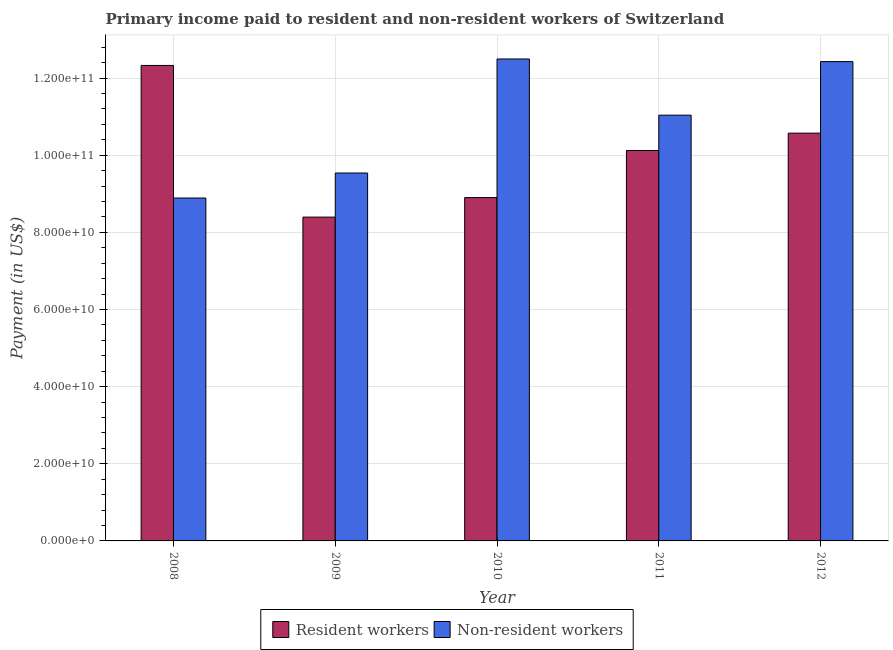How many different coloured bars are there?
Ensure brevity in your answer.  2. How many groups of bars are there?
Ensure brevity in your answer.  5. Are the number of bars per tick equal to the number of legend labels?
Ensure brevity in your answer.  Yes. Are the number of bars on each tick of the X-axis equal?
Provide a short and direct response. Yes. How many bars are there on the 1st tick from the left?
Your answer should be very brief. 2. How many bars are there on the 1st tick from the right?
Give a very brief answer. 2. What is the payment made to non-resident workers in 2011?
Your answer should be compact. 1.10e+11. Across all years, what is the maximum payment made to resident workers?
Keep it short and to the point. 1.23e+11. Across all years, what is the minimum payment made to non-resident workers?
Offer a terse response. 8.89e+1. In which year was the payment made to resident workers maximum?
Make the answer very short. 2008. In which year was the payment made to resident workers minimum?
Offer a terse response. 2009. What is the total payment made to resident workers in the graph?
Your answer should be very brief. 5.03e+11. What is the difference between the payment made to resident workers in 2008 and that in 2010?
Your answer should be very brief. 3.43e+1. What is the difference between the payment made to resident workers in 2008 and the payment made to non-resident workers in 2010?
Keep it short and to the point. 3.43e+1. What is the average payment made to non-resident workers per year?
Ensure brevity in your answer.  1.09e+11. In the year 2011, what is the difference between the payment made to resident workers and payment made to non-resident workers?
Give a very brief answer. 0. What is the ratio of the payment made to resident workers in 2008 to that in 2012?
Provide a short and direct response. 1.17. Is the payment made to resident workers in 2009 less than that in 2012?
Keep it short and to the point. Yes. Is the difference between the payment made to resident workers in 2011 and 2012 greater than the difference between the payment made to non-resident workers in 2011 and 2012?
Provide a succinct answer. No. What is the difference between the highest and the second highest payment made to resident workers?
Keep it short and to the point. 1.76e+1. What is the difference between the highest and the lowest payment made to non-resident workers?
Ensure brevity in your answer.  3.60e+1. What does the 1st bar from the left in 2012 represents?
Offer a terse response. Resident workers. What does the 1st bar from the right in 2011 represents?
Offer a terse response. Non-resident workers. How many bars are there?
Keep it short and to the point. 10. Are all the bars in the graph horizontal?
Provide a succinct answer. No. How many years are there in the graph?
Provide a short and direct response. 5. What is the difference between two consecutive major ticks on the Y-axis?
Your answer should be compact. 2.00e+1. Does the graph contain grids?
Offer a very short reply. Yes. How many legend labels are there?
Your answer should be very brief. 2. What is the title of the graph?
Keep it short and to the point. Primary income paid to resident and non-resident workers of Switzerland. What is the label or title of the Y-axis?
Your answer should be very brief. Payment (in US$). What is the Payment (in US$) in Resident workers in 2008?
Make the answer very short. 1.23e+11. What is the Payment (in US$) of Non-resident workers in 2008?
Provide a short and direct response. 8.89e+1. What is the Payment (in US$) of Resident workers in 2009?
Ensure brevity in your answer.  8.40e+1. What is the Payment (in US$) in Non-resident workers in 2009?
Ensure brevity in your answer.  9.54e+1. What is the Payment (in US$) of Resident workers in 2010?
Make the answer very short. 8.90e+1. What is the Payment (in US$) of Non-resident workers in 2010?
Offer a terse response. 1.25e+11. What is the Payment (in US$) in Resident workers in 2011?
Ensure brevity in your answer.  1.01e+11. What is the Payment (in US$) in Non-resident workers in 2011?
Offer a terse response. 1.10e+11. What is the Payment (in US$) in Resident workers in 2012?
Your answer should be very brief. 1.06e+11. What is the Payment (in US$) of Non-resident workers in 2012?
Offer a very short reply. 1.24e+11. Across all years, what is the maximum Payment (in US$) of Resident workers?
Keep it short and to the point. 1.23e+11. Across all years, what is the maximum Payment (in US$) of Non-resident workers?
Offer a terse response. 1.25e+11. Across all years, what is the minimum Payment (in US$) in Resident workers?
Keep it short and to the point. 8.40e+1. Across all years, what is the minimum Payment (in US$) in Non-resident workers?
Ensure brevity in your answer.  8.89e+1. What is the total Payment (in US$) of Resident workers in the graph?
Offer a terse response. 5.03e+11. What is the total Payment (in US$) of Non-resident workers in the graph?
Offer a terse response. 5.44e+11. What is the difference between the Payment (in US$) in Resident workers in 2008 and that in 2009?
Keep it short and to the point. 3.93e+1. What is the difference between the Payment (in US$) of Non-resident workers in 2008 and that in 2009?
Offer a very short reply. -6.48e+09. What is the difference between the Payment (in US$) of Resident workers in 2008 and that in 2010?
Ensure brevity in your answer.  3.43e+1. What is the difference between the Payment (in US$) in Non-resident workers in 2008 and that in 2010?
Offer a very short reply. -3.60e+1. What is the difference between the Payment (in US$) of Resident workers in 2008 and that in 2011?
Your answer should be very brief. 2.21e+1. What is the difference between the Payment (in US$) of Non-resident workers in 2008 and that in 2011?
Your response must be concise. -2.15e+1. What is the difference between the Payment (in US$) in Resident workers in 2008 and that in 2012?
Offer a terse response. 1.76e+1. What is the difference between the Payment (in US$) of Non-resident workers in 2008 and that in 2012?
Make the answer very short. -3.54e+1. What is the difference between the Payment (in US$) in Resident workers in 2009 and that in 2010?
Keep it short and to the point. -5.06e+09. What is the difference between the Payment (in US$) in Non-resident workers in 2009 and that in 2010?
Offer a very short reply. -2.96e+1. What is the difference between the Payment (in US$) of Resident workers in 2009 and that in 2011?
Ensure brevity in your answer.  -1.73e+1. What is the difference between the Payment (in US$) in Non-resident workers in 2009 and that in 2011?
Keep it short and to the point. -1.50e+1. What is the difference between the Payment (in US$) in Resident workers in 2009 and that in 2012?
Your answer should be compact. -2.18e+1. What is the difference between the Payment (in US$) in Non-resident workers in 2009 and that in 2012?
Provide a short and direct response. -2.89e+1. What is the difference between the Payment (in US$) of Resident workers in 2010 and that in 2011?
Keep it short and to the point. -1.22e+1. What is the difference between the Payment (in US$) in Non-resident workers in 2010 and that in 2011?
Your answer should be very brief. 1.46e+1. What is the difference between the Payment (in US$) of Resident workers in 2010 and that in 2012?
Your answer should be very brief. -1.67e+1. What is the difference between the Payment (in US$) in Non-resident workers in 2010 and that in 2012?
Keep it short and to the point. 6.81e+08. What is the difference between the Payment (in US$) of Resident workers in 2011 and that in 2012?
Provide a succinct answer. -4.50e+09. What is the difference between the Payment (in US$) in Non-resident workers in 2011 and that in 2012?
Your answer should be very brief. -1.39e+1. What is the difference between the Payment (in US$) of Resident workers in 2008 and the Payment (in US$) of Non-resident workers in 2009?
Ensure brevity in your answer.  2.79e+1. What is the difference between the Payment (in US$) of Resident workers in 2008 and the Payment (in US$) of Non-resident workers in 2010?
Offer a terse response. -1.68e+09. What is the difference between the Payment (in US$) in Resident workers in 2008 and the Payment (in US$) in Non-resident workers in 2011?
Ensure brevity in your answer.  1.29e+1. What is the difference between the Payment (in US$) in Resident workers in 2008 and the Payment (in US$) in Non-resident workers in 2012?
Provide a short and direct response. -9.99e+08. What is the difference between the Payment (in US$) of Resident workers in 2009 and the Payment (in US$) of Non-resident workers in 2010?
Your response must be concise. -4.10e+1. What is the difference between the Payment (in US$) of Resident workers in 2009 and the Payment (in US$) of Non-resident workers in 2011?
Your response must be concise. -2.64e+1. What is the difference between the Payment (in US$) of Resident workers in 2009 and the Payment (in US$) of Non-resident workers in 2012?
Offer a very short reply. -4.03e+1. What is the difference between the Payment (in US$) of Resident workers in 2010 and the Payment (in US$) of Non-resident workers in 2011?
Provide a succinct answer. -2.14e+1. What is the difference between the Payment (in US$) of Resident workers in 2010 and the Payment (in US$) of Non-resident workers in 2012?
Offer a very short reply. -3.53e+1. What is the difference between the Payment (in US$) in Resident workers in 2011 and the Payment (in US$) in Non-resident workers in 2012?
Provide a short and direct response. -2.31e+1. What is the average Payment (in US$) of Resident workers per year?
Provide a short and direct response. 1.01e+11. What is the average Payment (in US$) of Non-resident workers per year?
Offer a very short reply. 1.09e+11. In the year 2008, what is the difference between the Payment (in US$) of Resident workers and Payment (in US$) of Non-resident workers?
Make the answer very short. 3.44e+1. In the year 2009, what is the difference between the Payment (in US$) in Resident workers and Payment (in US$) in Non-resident workers?
Provide a short and direct response. -1.14e+1. In the year 2010, what is the difference between the Payment (in US$) in Resident workers and Payment (in US$) in Non-resident workers?
Give a very brief answer. -3.59e+1. In the year 2011, what is the difference between the Payment (in US$) of Resident workers and Payment (in US$) of Non-resident workers?
Provide a short and direct response. -9.16e+09. In the year 2012, what is the difference between the Payment (in US$) of Resident workers and Payment (in US$) of Non-resident workers?
Ensure brevity in your answer.  -1.86e+1. What is the ratio of the Payment (in US$) in Resident workers in 2008 to that in 2009?
Provide a short and direct response. 1.47. What is the ratio of the Payment (in US$) of Non-resident workers in 2008 to that in 2009?
Offer a terse response. 0.93. What is the ratio of the Payment (in US$) in Resident workers in 2008 to that in 2010?
Give a very brief answer. 1.38. What is the ratio of the Payment (in US$) in Non-resident workers in 2008 to that in 2010?
Offer a very short reply. 0.71. What is the ratio of the Payment (in US$) of Resident workers in 2008 to that in 2011?
Your answer should be compact. 1.22. What is the ratio of the Payment (in US$) of Non-resident workers in 2008 to that in 2011?
Ensure brevity in your answer.  0.81. What is the ratio of the Payment (in US$) in Resident workers in 2008 to that in 2012?
Ensure brevity in your answer.  1.17. What is the ratio of the Payment (in US$) of Non-resident workers in 2008 to that in 2012?
Keep it short and to the point. 0.72. What is the ratio of the Payment (in US$) of Resident workers in 2009 to that in 2010?
Ensure brevity in your answer.  0.94. What is the ratio of the Payment (in US$) in Non-resident workers in 2009 to that in 2010?
Make the answer very short. 0.76. What is the ratio of the Payment (in US$) in Resident workers in 2009 to that in 2011?
Ensure brevity in your answer.  0.83. What is the ratio of the Payment (in US$) in Non-resident workers in 2009 to that in 2011?
Your response must be concise. 0.86. What is the ratio of the Payment (in US$) of Resident workers in 2009 to that in 2012?
Offer a terse response. 0.79. What is the ratio of the Payment (in US$) of Non-resident workers in 2009 to that in 2012?
Offer a very short reply. 0.77. What is the ratio of the Payment (in US$) in Resident workers in 2010 to that in 2011?
Give a very brief answer. 0.88. What is the ratio of the Payment (in US$) of Non-resident workers in 2010 to that in 2011?
Your answer should be compact. 1.13. What is the ratio of the Payment (in US$) of Resident workers in 2010 to that in 2012?
Keep it short and to the point. 0.84. What is the ratio of the Payment (in US$) in Non-resident workers in 2010 to that in 2012?
Provide a succinct answer. 1.01. What is the ratio of the Payment (in US$) of Resident workers in 2011 to that in 2012?
Offer a terse response. 0.96. What is the ratio of the Payment (in US$) in Non-resident workers in 2011 to that in 2012?
Provide a short and direct response. 0.89. What is the difference between the highest and the second highest Payment (in US$) in Resident workers?
Ensure brevity in your answer.  1.76e+1. What is the difference between the highest and the second highest Payment (in US$) of Non-resident workers?
Give a very brief answer. 6.81e+08. What is the difference between the highest and the lowest Payment (in US$) of Resident workers?
Provide a succinct answer. 3.93e+1. What is the difference between the highest and the lowest Payment (in US$) in Non-resident workers?
Provide a succinct answer. 3.60e+1. 